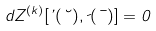Convert formula to latex. <formula><loc_0><loc_0><loc_500><loc_500>d Z ^ { ( k ) } [ \varphi ( \lambda ) , \psi ( \mu ) ] = 0</formula> 